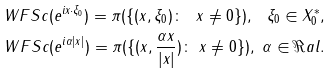<formula> <loc_0><loc_0><loc_500><loc_500>\ W F S c ( e ^ { i x \cdot \xi _ { 0 } } ) = \pi ( \{ ( x , \xi _ { 0 } ) \colon \ x \neq 0 \} ) , \ \xi _ { 0 } \in X _ { 0 } ^ { * } , \\ \ W F S c ( e ^ { i \alpha | x | } ) = \pi ( \{ ( x , \frac { \alpha x } { | x | } ) \colon \ x \neq 0 \} ) , \ \alpha \in \Re a l .</formula> 